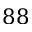Convert formula to latex. <formula><loc_0><loc_0><loc_500><loc_500>8 8</formula> 